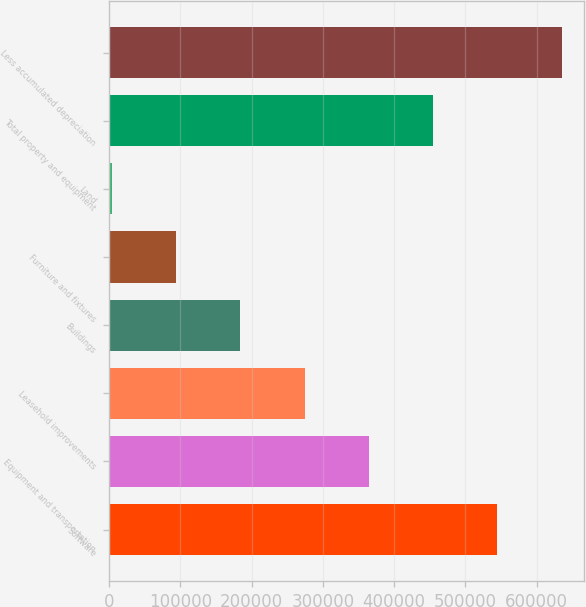Convert chart to OTSL. <chart><loc_0><loc_0><loc_500><loc_500><bar_chart><fcel>Software<fcel>Equipment and transportation<fcel>Leasehold improvements<fcel>Buildings<fcel>Furniture and fixtures<fcel>Land<fcel>Total property and equipment<fcel>Less accumulated depreciation<nl><fcel>544871<fcel>364531<fcel>274362<fcel>184192<fcel>94022.6<fcel>3853<fcel>454701<fcel>635040<nl></chart> 